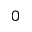<formula> <loc_0><loc_0><loc_500><loc_500>0</formula> 